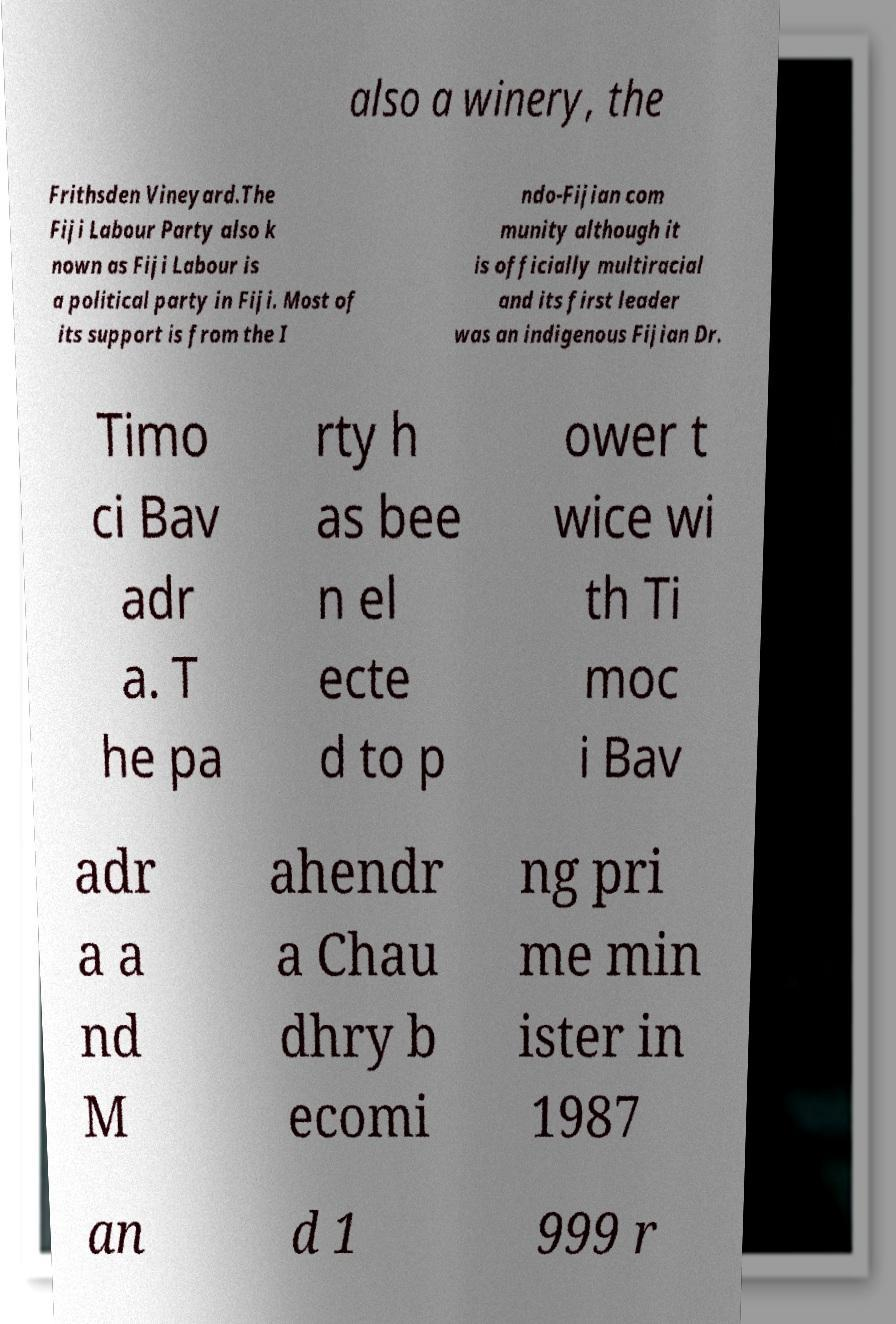Can you accurately transcribe the text from the provided image for me? also a winery, the Frithsden Vineyard.The Fiji Labour Party also k nown as Fiji Labour is a political party in Fiji. Most of its support is from the I ndo-Fijian com munity although it is officially multiracial and its first leader was an indigenous Fijian Dr. Timo ci Bav adr a. T he pa rty h as bee n el ecte d to p ower t wice wi th Ti moc i Bav adr a a nd M ahendr a Chau dhry b ecomi ng pri me min ister in 1987 an d 1 999 r 